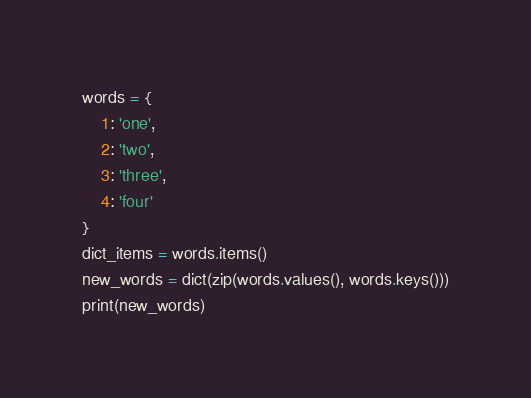<code> <loc_0><loc_0><loc_500><loc_500><_Python_>words = {
    1: 'one',
    2: 'two',
    3: 'three',
    4: 'four'
}
dict_items = words.items()
new_words = dict(zip(words.values(), words.keys()))
print(new_words)







</code> 